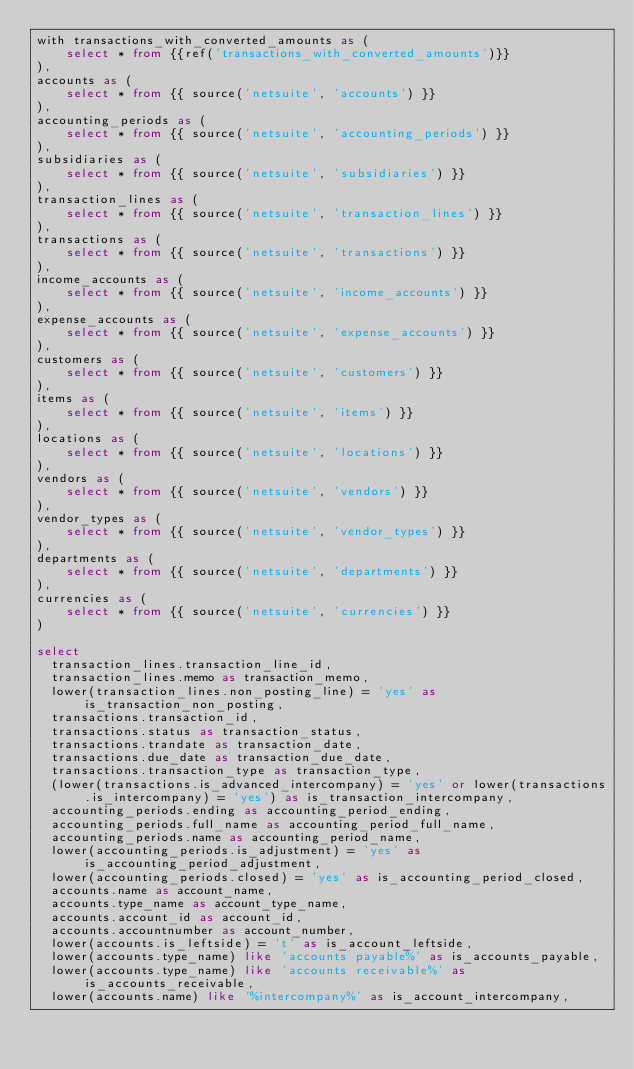<code> <loc_0><loc_0><loc_500><loc_500><_SQL_>with transactions_with_converted_amounts as (
    select * from {{ref('transactions_with_converted_amounts')}}
),
accounts as (
    select * from {{ source('netsuite', 'accounts') }}
),
accounting_periods as (
    select * from {{ source('netsuite', 'accounting_periods') }}
),
subsidiaries as (
    select * from {{ source('netsuite', 'subsidiaries') }}
),
transaction_lines as (
    select * from {{ source('netsuite', 'transaction_lines') }}
),
transactions as (
    select * from {{ source('netsuite', 'transactions') }}
),
income_accounts as (
    select * from {{ source('netsuite', 'income_accounts') }}
),
expense_accounts as (
    select * from {{ source('netsuite', 'expense_accounts') }}
),
customers as (
    select * from {{ source('netsuite', 'customers') }}
),
items as (
    select * from {{ source('netsuite', 'items') }}
),
locations as (
    select * from {{ source('netsuite', 'locations') }}
),
vendors as (
    select * from {{ source('netsuite', 'vendors') }}
),
vendor_types as (
    select * from {{ source('netsuite', 'vendor_types') }}
),
departments as (
    select * from {{ source('netsuite', 'departments') }}
),
currencies as (
    select * from {{ source('netsuite', 'currencies') }}
)

select
  transaction_lines.transaction_line_id,
  transaction_lines.memo as transaction_memo,
  lower(transaction_lines.non_posting_line) = 'yes' as is_transaction_non_posting,
  transactions.transaction_id,
  transactions.status as transaction_status,
  transactions.trandate as transaction_date,
  transactions.due_date as transaction_due_date,
  transactions.transaction_type as transaction_type,
  (lower(transactions.is_advanced_intercompany) = 'yes' or lower(transactions.is_intercompany) = 'yes') as is_transaction_intercompany,
  accounting_periods.ending as accounting_period_ending,
  accounting_periods.full_name as accounting_period_full_name,
  accounting_periods.name as accounting_period_name,
  lower(accounting_periods.is_adjustment) = 'yes' as is_accounting_period_adjustment,
  lower(accounting_periods.closed) = 'yes' as is_accounting_period_closed,
  accounts.name as account_name,
  accounts.type_name as account_type_name,
  accounts.account_id as account_id,
  accounts.accountnumber as account_number,
  lower(accounts.is_leftside) = 't' as is_account_leftside,
  lower(accounts.type_name) like 'accounts payable%' as is_accounts_payable,
  lower(accounts.type_name) like 'accounts receivable%' as is_accounts_receivable,
  lower(accounts.name) like '%intercompany%' as is_account_intercompany,</code> 